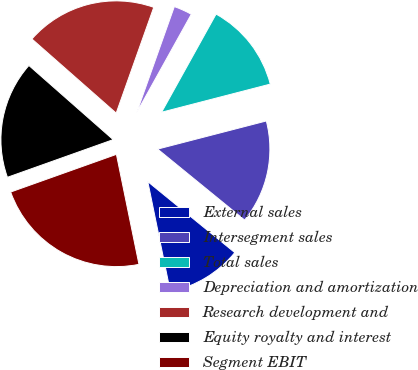Convert chart. <chart><loc_0><loc_0><loc_500><loc_500><pie_chart><fcel>External sales<fcel>Intersegment sales<fcel>Total sales<fcel>Depreciation and amortization<fcel>Research development and<fcel>Equity royalty and interest<fcel>Segment EBIT<nl><fcel>10.89%<fcel>14.92%<fcel>12.9%<fcel>2.64%<fcel>18.94%<fcel>16.93%<fcel>22.77%<nl></chart> 